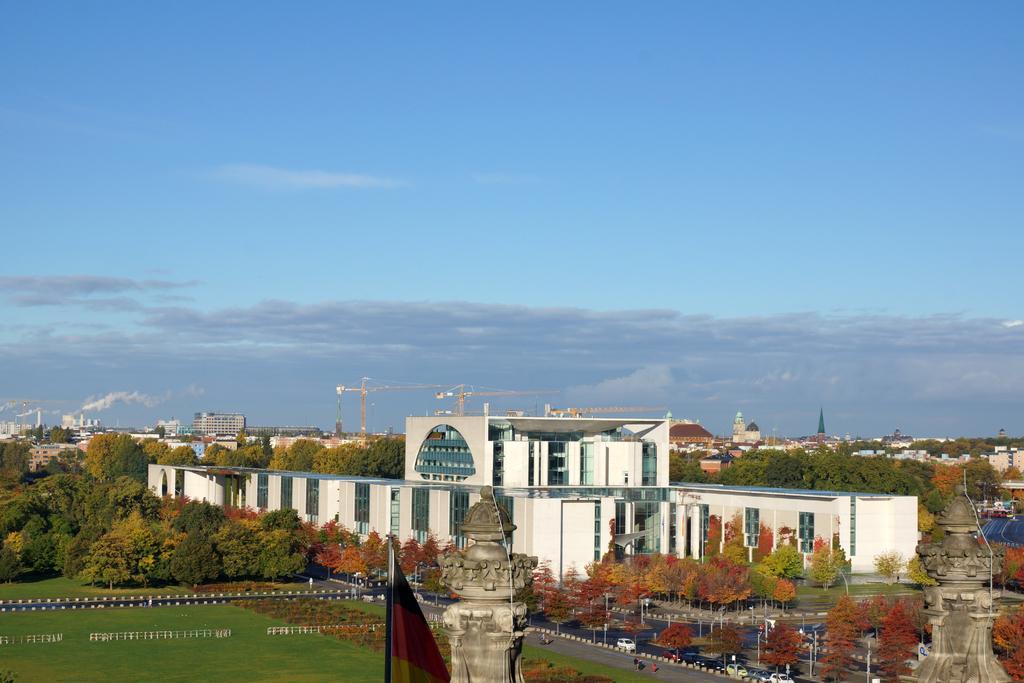In one or two sentences, can you explain what this image depicts? At the bottom of the image there are towers, buildings, trees and roads. At the top there is sky. 